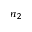<formula> <loc_0><loc_0><loc_500><loc_500>n _ { 2 }</formula> 